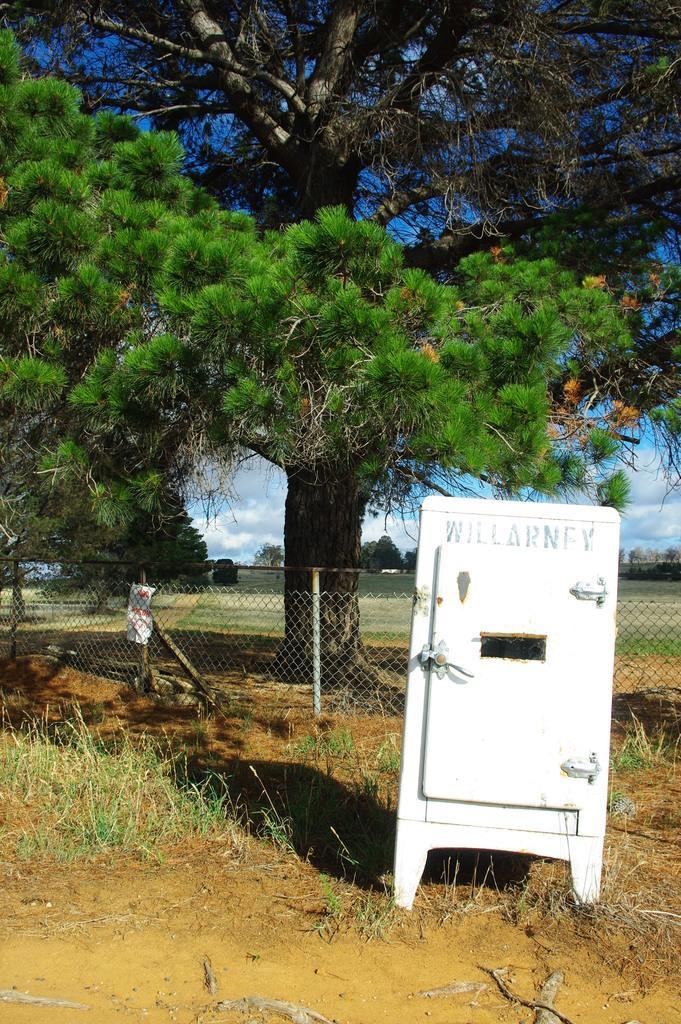In one or two sentences, can you explain what this image depicts? In this image we can see many trees. There is a cloudy sky in the image. There is a grassy land in the image. There is a fencing and a paper on it. There is an object in the image. 